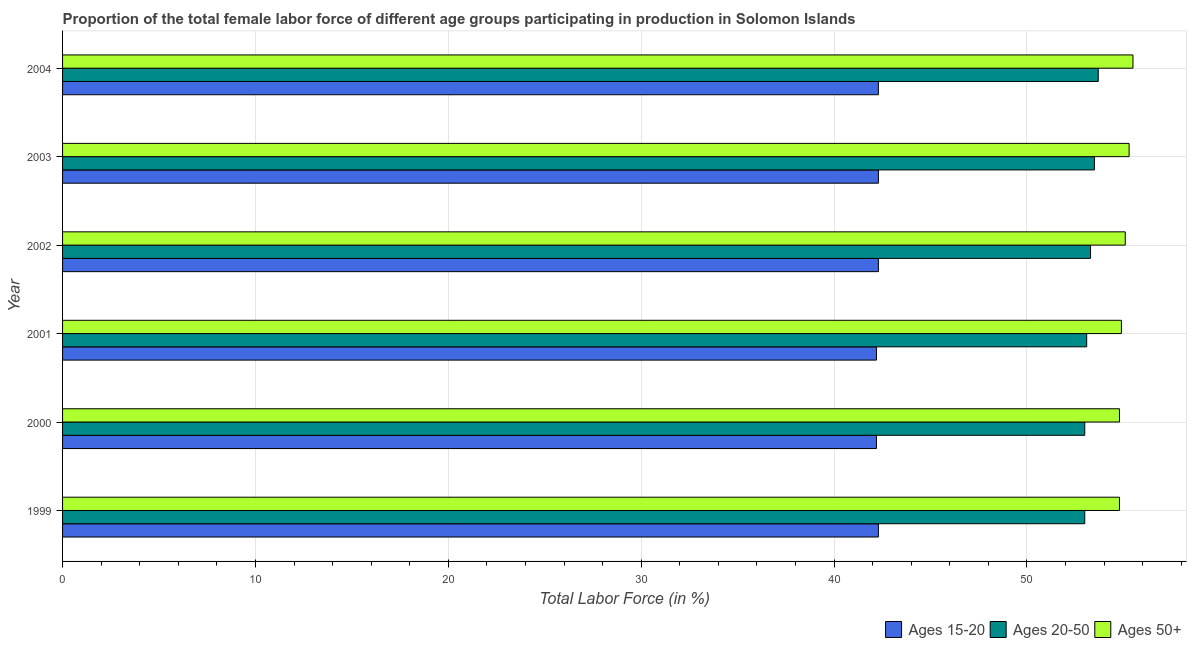How many different coloured bars are there?
Give a very brief answer. 3. How many groups of bars are there?
Provide a succinct answer. 6. Are the number of bars on each tick of the Y-axis equal?
Your answer should be very brief. Yes. How many bars are there on the 5th tick from the bottom?
Offer a very short reply. 3. In how many cases, is the number of bars for a given year not equal to the number of legend labels?
Your answer should be compact. 0. What is the percentage of female labor force within the age group 20-50 in 2002?
Keep it short and to the point. 53.3. Across all years, what is the maximum percentage of female labor force within the age group 20-50?
Your answer should be very brief. 53.7. Across all years, what is the minimum percentage of female labor force above age 50?
Your answer should be very brief. 54.8. What is the total percentage of female labor force above age 50 in the graph?
Ensure brevity in your answer.  330.4. What is the difference between the percentage of female labor force within the age group 15-20 in 2003 and that in 2004?
Ensure brevity in your answer.  0. What is the difference between the percentage of female labor force within the age group 20-50 in 2003 and the percentage of female labor force above age 50 in 1999?
Your answer should be very brief. -1.3. What is the average percentage of female labor force within the age group 15-20 per year?
Provide a short and direct response. 42.27. In how many years, is the percentage of female labor force above age 50 greater than 48 %?
Ensure brevity in your answer.  6. What is the ratio of the percentage of female labor force within the age group 20-50 in 1999 to that in 2001?
Offer a very short reply. 1. Is the percentage of female labor force above age 50 in 2002 less than that in 2003?
Keep it short and to the point. Yes. What is the difference between the highest and the second highest percentage of female labor force above age 50?
Offer a terse response. 0.2. What does the 3rd bar from the top in 2004 represents?
Ensure brevity in your answer.  Ages 15-20. What does the 1st bar from the bottom in 1999 represents?
Provide a succinct answer. Ages 15-20. Is it the case that in every year, the sum of the percentage of female labor force within the age group 15-20 and percentage of female labor force within the age group 20-50 is greater than the percentage of female labor force above age 50?
Your answer should be very brief. Yes. Are all the bars in the graph horizontal?
Provide a succinct answer. Yes. Does the graph contain any zero values?
Offer a terse response. No. Does the graph contain grids?
Your response must be concise. Yes. How are the legend labels stacked?
Provide a short and direct response. Horizontal. What is the title of the graph?
Your answer should be compact. Proportion of the total female labor force of different age groups participating in production in Solomon Islands. What is the Total Labor Force (in %) in Ages 15-20 in 1999?
Your response must be concise. 42.3. What is the Total Labor Force (in %) in Ages 50+ in 1999?
Your answer should be compact. 54.8. What is the Total Labor Force (in %) of Ages 15-20 in 2000?
Your answer should be compact. 42.2. What is the Total Labor Force (in %) in Ages 50+ in 2000?
Offer a very short reply. 54.8. What is the Total Labor Force (in %) of Ages 15-20 in 2001?
Offer a terse response. 42.2. What is the Total Labor Force (in %) in Ages 20-50 in 2001?
Ensure brevity in your answer.  53.1. What is the Total Labor Force (in %) in Ages 50+ in 2001?
Make the answer very short. 54.9. What is the Total Labor Force (in %) of Ages 15-20 in 2002?
Offer a terse response. 42.3. What is the Total Labor Force (in %) in Ages 20-50 in 2002?
Provide a short and direct response. 53.3. What is the Total Labor Force (in %) in Ages 50+ in 2002?
Offer a very short reply. 55.1. What is the Total Labor Force (in %) of Ages 15-20 in 2003?
Offer a very short reply. 42.3. What is the Total Labor Force (in %) of Ages 20-50 in 2003?
Offer a very short reply. 53.5. What is the Total Labor Force (in %) of Ages 50+ in 2003?
Offer a very short reply. 55.3. What is the Total Labor Force (in %) of Ages 15-20 in 2004?
Give a very brief answer. 42.3. What is the Total Labor Force (in %) in Ages 20-50 in 2004?
Give a very brief answer. 53.7. What is the Total Labor Force (in %) in Ages 50+ in 2004?
Make the answer very short. 55.5. Across all years, what is the maximum Total Labor Force (in %) in Ages 15-20?
Provide a short and direct response. 42.3. Across all years, what is the maximum Total Labor Force (in %) in Ages 20-50?
Ensure brevity in your answer.  53.7. Across all years, what is the maximum Total Labor Force (in %) in Ages 50+?
Make the answer very short. 55.5. Across all years, what is the minimum Total Labor Force (in %) of Ages 15-20?
Provide a succinct answer. 42.2. Across all years, what is the minimum Total Labor Force (in %) of Ages 50+?
Offer a terse response. 54.8. What is the total Total Labor Force (in %) in Ages 15-20 in the graph?
Provide a succinct answer. 253.6. What is the total Total Labor Force (in %) in Ages 20-50 in the graph?
Give a very brief answer. 319.6. What is the total Total Labor Force (in %) of Ages 50+ in the graph?
Provide a succinct answer. 330.4. What is the difference between the Total Labor Force (in %) of Ages 15-20 in 1999 and that in 2000?
Your response must be concise. 0.1. What is the difference between the Total Labor Force (in %) of Ages 50+ in 1999 and that in 2000?
Your response must be concise. 0. What is the difference between the Total Labor Force (in %) of Ages 20-50 in 1999 and that in 2002?
Your answer should be very brief. -0.3. What is the difference between the Total Labor Force (in %) in Ages 15-20 in 1999 and that in 2003?
Provide a succinct answer. 0. What is the difference between the Total Labor Force (in %) in Ages 20-50 in 1999 and that in 2003?
Give a very brief answer. -0.5. What is the difference between the Total Labor Force (in %) in Ages 15-20 in 1999 and that in 2004?
Offer a very short reply. 0. What is the difference between the Total Labor Force (in %) in Ages 50+ in 2000 and that in 2002?
Offer a very short reply. -0.3. What is the difference between the Total Labor Force (in %) in Ages 15-20 in 2000 and that in 2003?
Ensure brevity in your answer.  -0.1. What is the difference between the Total Labor Force (in %) of Ages 50+ in 2000 and that in 2003?
Your answer should be very brief. -0.5. What is the difference between the Total Labor Force (in %) in Ages 15-20 in 2000 and that in 2004?
Keep it short and to the point. -0.1. What is the difference between the Total Labor Force (in %) of Ages 50+ in 2000 and that in 2004?
Ensure brevity in your answer.  -0.7. What is the difference between the Total Labor Force (in %) in Ages 15-20 in 2001 and that in 2002?
Provide a short and direct response. -0.1. What is the difference between the Total Labor Force (in %) of Ages 50+ in 2001 and that in 2002?
Keep it short and to the point. -0.2. What is the difference between the Total Labor Force (in %) of Ages 15-20 in 2001 and that in 2003?
Your response must be concise. -0.1. What is the difference between the Total Labor Force (in %) of Ages 20-50 in 2001 and that in 2003?
Give a very brief answer. -0.4. What is the difference between the Total Labor Force (in %) in Ages 50+ in 2001 and that in 2003?
Keep it short and to the point. -0.4. What is the difference between the Total Labor Force (in %) of Ages 50+ in 2001 and that in 2004?
Provide a short and direct response. -0.6. What is the difference between the Total Labor Force (in %) in Ages 15-20 in 2002 and that in 2003?
Provide a succinct answer. 0. What is the difference between the Total Labor Force (in %) in Ages 20-50 in 2002 and that in 2003?
Your answer should be very brief. -0.2. What is the difference between the Total Labor Force (in %) in Ages 50+ in 2002 and that in 2003?
Make the answer very short. -0.2. What is the difference between the Total Labor Force (in %) in Ages 15-20 in 2002 and that in 2004?
Ensure brevity in your answer.  0. What is the difference between the Total Labor Force (in %) of Ages 20-50 in 2003 and that in 2004?
Offer a very short reply. -0.2. What is the difference between the Total Labor Force (in %) in Ages 50+ in 2003 and that in 2004?
Provide a succinct answer. -0.2. What is the difference between the Total Labor Force (in %) of Ages 15-20 in 1999 and the Total Labor Force (in %) of Ages 50+ in 2000?
Your answer should be very brief. -12.5. What is the difference between the Total Labor Force (in %) in Ages 15-20 in 1999 and the Total Labor Force (in %) in Ages 20-50 in 2001?
Ensure brevity in your answer.  -10.8. What is the difference between the Total Labor Force (in %) in Ages 15-20 in 1999 and the Total Labor Force (in %) in Ages 50+ in 2001?
Offer a terse response. -12.6. What is the difference between the Total Labor Force (in %) in Ages 20-50 in 1999 and the Total Labor Force (in %) in Ages 50+ in 2001?
Keep it short and to the point. -1.9. What is the difference between the Total Labor Force (in %) in Ages 15-20 in 1999 and the Total Labor Force (in %) in Ages 50+ in 2002?
Provide a short and direct response. -12.8. What is the difference between the Total Labor Force (in %) of Ages 20-50 in 1999 and the Total Labor Force (in %) of Ages 50+ in 2002?
Give a very brief answer. -2.1. What is the difference between the Total Labor Force (in %) of Ages 15-20 in 1999 and the Total Labor Force (in %) of Ages 50+ in 2003?
Make the answer very short. -13. What is the difference between the Total Labor Force (in %) of Ages 20-50 in 1999 and the Total Labor Force (in %) of Ages 50+ in 2003?
Your answer should be compact. -2.3. What is the difference between the Total Labor Force (in %) in Ages 15-20 in 2000 and the Total Labor Force (in %) in Ages 50+ in 2002?
Keep it short and to the point. -12.9. What is the difference between the Total Labor Force (in %) in Ages 15-20 in 2000 and the Total Labor Force (in %) in Ages 50+ in 2003?
Give a very brief answer. -13.1. What is the difference between the Total Labor Force (in %) in Ages 20-50 in 2000 and the Total Labor Force (in %) in Ages 50+ in 2003?
Offer a terse response. -2.3. What is the difference between the Total Labor Force (in %) in Ages 15-20 in 2000 and the Total Labor Force (in %) in Ages 50+ in 2004?
Your answer should be compact. -13.3. What is the difference between the Total Labor Force (in %) in Ages 20-50 in 2000 and the Total Labor Force (in %) in Ages 50+ in 2004?
Your response must be concise. -2.5. What is the difference between the Total Labor Force (in %) of Ages 15-20 in 2001 and the Total Labor Force (in %) of Ages 50+ in 2002?
Your response must be concise. -12.9. What is the difference between the Total Labor Force (in %) of Ages 20-50 in 2001 and the Total Labor Force (in %) of Ages 50+ in 2002?
Make the answer very short. -2. What is the difference between the Total Labor Force (in %) in Ages 15-20 in 2001 and the Total Labor Force (in %) in Ages 20-50 in 2003?
Offer a terse response. -11.3. What is the difference between the Total Labor Force (in %) in Ages 15-20 in 2001 and the Total Labor Force (in %) in Ages 50+ in 2003?
Your answer should be very brief. -13.1. What is the difference between the Total Labor Force (in %) of Ages 20-50 in 2001 and the Total Labor Force (in %) of Ages 50+ in 2003?
Your response must be concise. -2.2. What is the difference between the Total Labor Force (in %) of Ages 15-20 in 2001 and the Total Labor Force (in %) of Ages 50+ in 2004?
Offer a very short reply. -13.3. What is the difference between the Total Labor Force (in %) of Ages 20-50 in 2001 and the Total Labor Force (in %) of Ages 50+ in 2004?
Provide a succinct answer. -2.4. What is the difference between the Total Labor Force (in %) in Ages 15-20 in 2002 and the Total Labor Force (in %) in Ages 20-50 in 2003?
Provide a short and direct response. -11.2. What is the difference between the Total Labor Force (in %) in Ages 15-20 in 2002 and the Total Labor Force (in %) in Ages 50+ in 2003?
Your response must be concise. -13. What is the difference between the Total Labor Force (in %) of Ages 15-20 in 2002 and the Total Labor Force (in %) of Ages 20-50 in 2004?
Ensure brevity in your answer.  -11.4. What is the difference between the Total Labor Force (in %) in Ages 20-50 in 2002 and the Total Labor Force (in %) in Ages 50+ in 2004?
Offer a terse response. -2.2. What is the difference between the Total Labor Force (in %) of Ages 15-20 in 2003 and the Total Labor Force (in %) of Ages 50+ in 2004?
Make the answer very short. -13.2. What is the average Total Labor Force (in %) in Ages 15-20 per year?
Give a very brief answer. 42.27. What is the average Total Labor Force (in %) in Ages 20-50 per year?
Provide a short and direct response. 53.27. What is the average Total Labor Force (in %) of Ages 50+ per year?
Offer a very short reply. 55.07. In the year 1999, what is the difference between the Total Labor Force (in %) in Ages 15-20 and Total Labor Force (in %) in Ages 20-50?
Keep it short and to the point. -10.7. In the year 1999, what is the difference between the Total Labor Force (in %) of Ages 15-20 and Total Labor Force (in %) of Ages 50+?
Keep it short and to the point. -12.5. In the year 2000, what is the difference between the Total Labor Force (in %) in Ages 20-50 and Total Labor Force (in %) in Ages 50+?
Offer a very short reply. -1.8. In the year 2001, what is the difference between the Total Labor Force (in %) of Ages 15-20 and Total Labor Force (in %) of Ages 20-50?
Provide a short and direct response. -10.9. In the year 2001, what is the difference between the Total Labor Force (in %) in Ages 15-20 and Total Labor Force (in %) in Ages 50+?
Your answer should be compact. -12.7. In the year 2001, what is the difference between the Total Labor Force (in %) of Ages 20-50 and Total Labor Force (in %) of Ages 50+?
Provide a succinct answer. -1.8. In the year 2002, what is the difference between the Total Labor Force (in %) in Ages 15-20 and Total Labor Force (in %) in Ages 20-50?
Your response must be concise. -11. In the year 2003, what is the difference between the Total Labor Force (in %) in Ages 15-20 and Total Labor Force (in %) in Ages 20-50?
Give a very brief answer. -11.2. In the year 2003, what is the difference between the Total Labor Force (in %) in Ages 20-50 and Total Labor Force (in %) in Ages 50+?
Keep it short and to the point. -1.8. What is the ratio of the Total Labor Force (in %) in Ages 15-20 in 1999 to that in 2000?
Provide a succinct answer. 1. What is the ratio of the Total Labor Force (in %) of Ages 50+ in 1999 to that in 2000?
Give a very brief answer. 1. What is the ratio of the Total Labor Force (in %) of Ages 15-20 in 1999 to that in 2001?
Ensure brevity in your answer.  1. What is the ratio of the Total Labor Force (in %) of Ages 20-50 in 1999 to that in 2001?
Provide a short and direct response. 1. What is the ratio of the Total Labor Force (in %) in Ages 15-20 in 1999 to that in 2002?
Give a very brief answer. 1. What is the ratio of the Total Labor Force (in %) of Ages 20-50 in 1999 to that in 2003?
Provide a succinct answer. 0.99. What is the ratio of the Total Labor Force (in %) of Ages 50+ in 1999 to that in 2003?
Make the answer very short. 0.99. What is the ratio of the Total Labor Force (in %) of Ages 50+ in 1999 to that in 2004?
Provide a succinct answer. 0.99. What is the ratio of the Total Labor Force (in %) of Ages 20-50 in 2000 to that in 2001?
Keep it short and to the point. 1. What is the ratio of the Total Labor Force (in %) in Ages 50+ in 2000 to that in 2001?
Your answer should be very brief. 1. What is the ratio of the Total Labor Force (in %) in Ages 20-50 in 2000 to that in 2002?
Keep it short and to the point. 0.99. What is the ratio of the Total Labor Force (in %) in Ages 20-50 in 2000 to that in 2003?
Provide a succinct answer. 0.99. What is the ratio of the Total Labor Force (in %) in Ages 15-20 in 2000 to that in 2004?
Your response must be concise. 1. What is the ratio of the Total Labor Force (in %) in Ages 50+ in 2000 to that in 2004?
Ensure brevity in your answer.  0.99. What is the ratio of the Total Labor Force (in %) in Ages 50+ in 2001 to that in 2002?
Provide a short and direct response. 1. What is the ratio of the Total Labor Force (in %) in Ages 15-20 in 2001 to that in 2003?
Offer a very short reply. 1. What is the ratio of the Total Labor Force (in %) of Ages 50+ in 2001 to that in 2003?
Keep it short and to the point. 0.99. What is the ratio of the Total Labor Force (in %) in Ages 50+ in 2001 to that in 2004?
Make the answer very short. 0.99. What is the ratio of the Total Labor Force (in %) in Ages 15-20 in 2002 to that in 2003?
Your response must be concise. 1. What is the ratio of the Total Labor Force (in %) in Ages 20-50 in 2002 to that in 2003?
Provide a short and direct response. 1. What is the ratio of the Total Labor Force (in %) in Ages 50+ in 2002 to that in 2003?
Provide a short and direct response. 1. What is the ratio of the Total Labor Force (in %) of Ages 15-20 in 2002 to that in 2004?
Ensure brevity in your answer.  1. What is the ratio of the Total Labor Force (in %) in Ages 20-50 in 2002 to that in 2004?
Provide a succinct answer. 0.99. What is the ratio of the Total Labor Force (in %) in Ages 15-20 in 2003 to that in 2004?
Provide a succinct answer. 1. What is the ratio of the Total Labor Force (in %) in Ages 20-50 in 2003 to that in 2004?
Provide a short and direct response. 1. What is the difference between the highest and the second highest Total Labor Force (in %) in Ages 15-20?
Your response must be concise. 0. What is the difference between the highest and the lowest Total Labor Force (in %) in Ages 15-20?
Ensure brevity in your answer.  0.1. What is the difference between the highest and the lowest Total Labor Force (in %) in Ages 20-50?
Make the answer very short. 0.7. What is the difference between the highest and the lowest Total Labor Force (in %) of Ages 50+?
Your answer should be very brief. 0.7. 